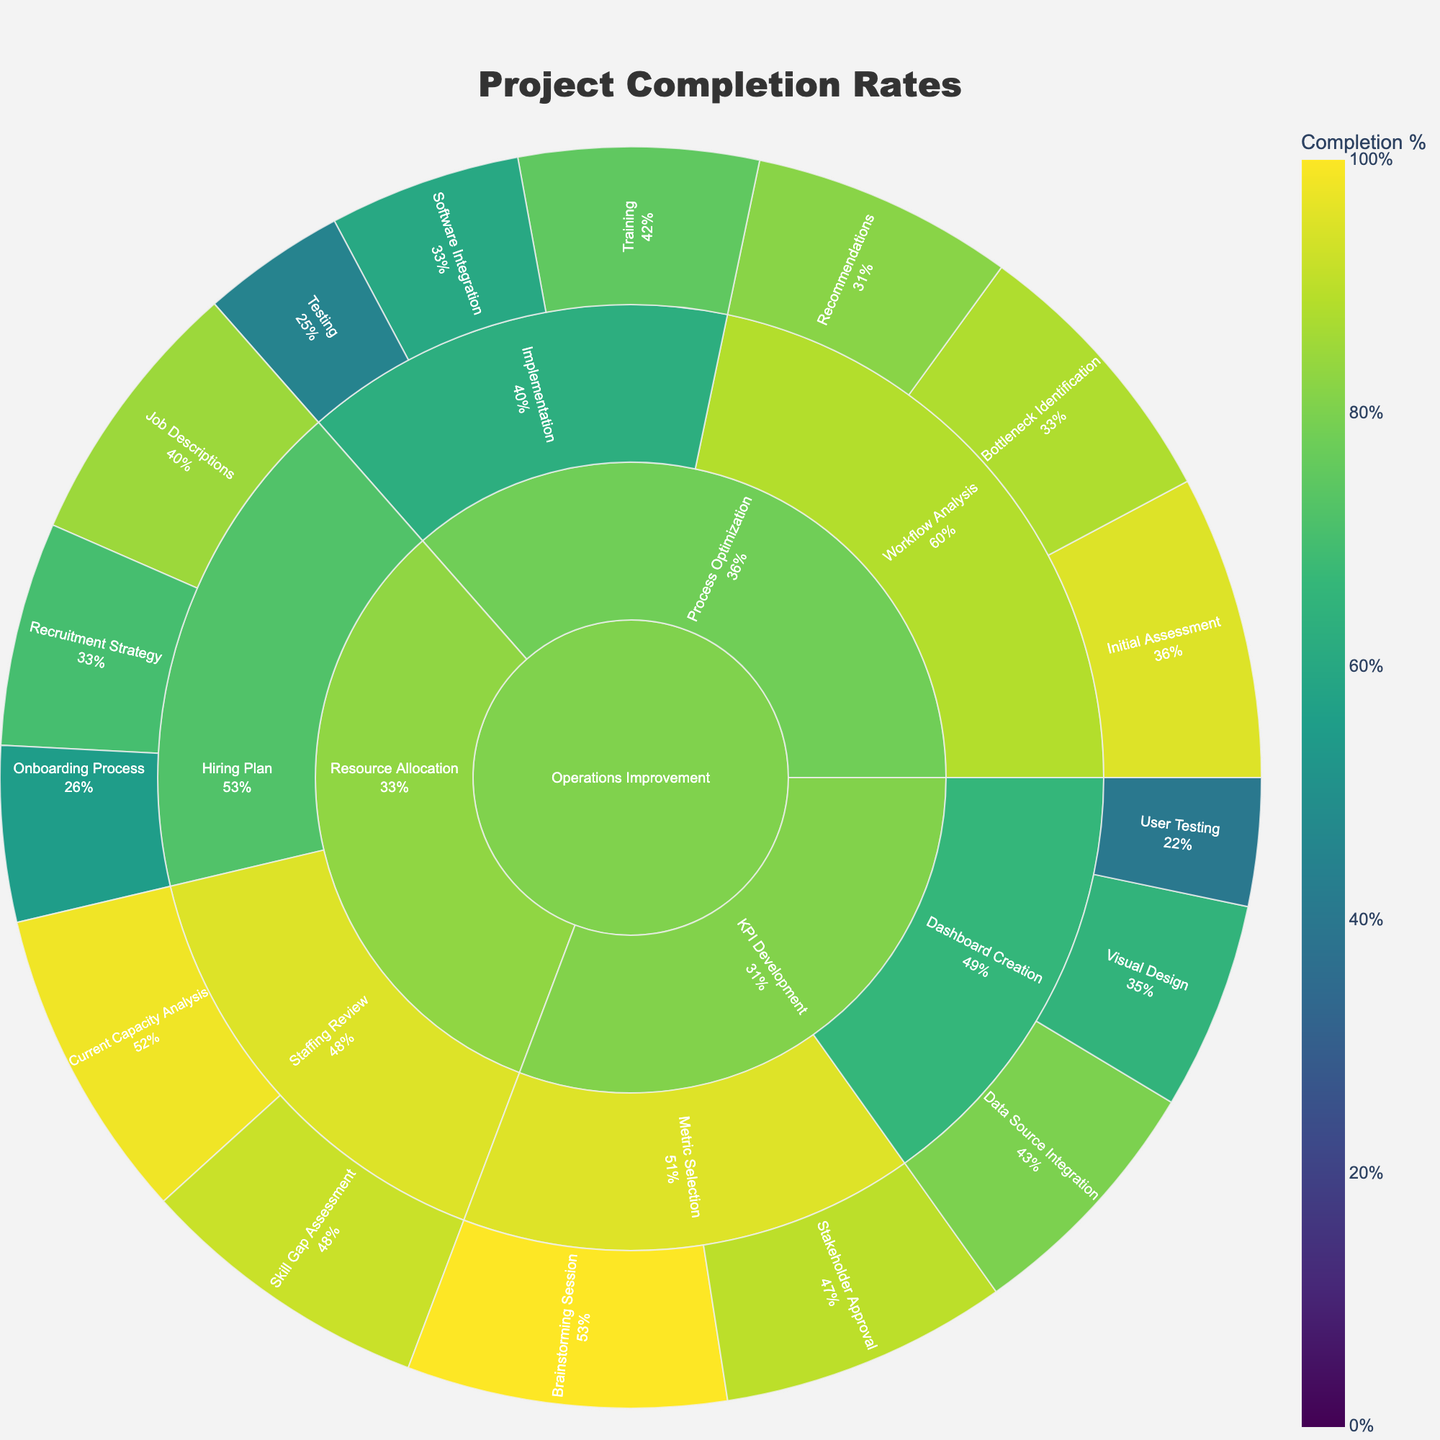What's the title of the figure? The title appears prominently at the top center of the figure. It reads "Project Completion Rates."
Answer: Project Completion Rates What color scale is used for indicating completion rates? The figure uses the Viridis color scale for representing completion percentages, transitioning from dark purple to yellow-green as completion rates increase.
Answer: Viridis How is the 'Resource Allocation' task performing overall compared to 'Process Optimization'? 'Resource Allocation' maintains higher completion rates across its subtasks and milestones compared to 'Process Optimization.' Observing completion rates within each segment, 'Resource Allocation' typically shows higher values.
Answer: Better What's the specific completion rate for 'Visual Design' under 'Dashboard Creation' in 'KPI Development'? By locating the 'Visual Design' milestone within the 'Dashboard Creation' subtask of 'KPI Development,' the completion rate is seen to be 65%.
Answer: 65% Which milestone under 'Hiring Plan' has the lowest completion rate, and what is it? Under 'Hiring Plan,' the milestones visible are 'Job Descriptions,' 'Recruitment Strategy,' and 'Onboarding Process.' 'Onboarding Process' has the lowest completion rate at 55%.
Answer: Onboarding Process, 55% What is the average completion rate of milestones within 'Workflow Analysis'? There are three milestones under ‘Workflow Analysis’: 'Initial Assessment' (95%), 'Bottleneck Identification' (88%), and 'Recommendations' (82%). The average is calculated as (95 + 88 + 82) / 3 = 88.33%.
Answer: 88.33% Which milestone has the highest completion percentage in the entire project? Observing the overall completion rates for all milestones, 'Brainstorming Session' under 'Metric Selection' in 'KPI Development' has the highest completion rate of 100%.
Answer: Brainstorming Session Compare the completion rates for 'Training' and 'Software Integration' in 'Implementation.' Which is higher? The milestone 'Training' has a completion rate of 75%, whereas 'Software Integration' has a completion rate of 60%. Comparing these describes 'Training' as higher than 'Software Integration.'
Answer: Training How do the completion rates of milestones in 'Hiring Plan' compare to those in 'Staffing Review'? The 'Hiring Plan' milestones range from 55% to 85%, while 'Staffing Review' milestones are 92% (Skill Gap Assessment) and 98% (Current Capacity Analysis). Milestones under 'Staffing Review' have higher completion rates than those under 'Hiring Plan.'
Answer: Higher in Staffing Review 